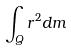Convert formula to latex. <formula><loc_0><loc_0><loc_500><loc_500>\int _ { Q } r ^ { 2 } d m</formula> 